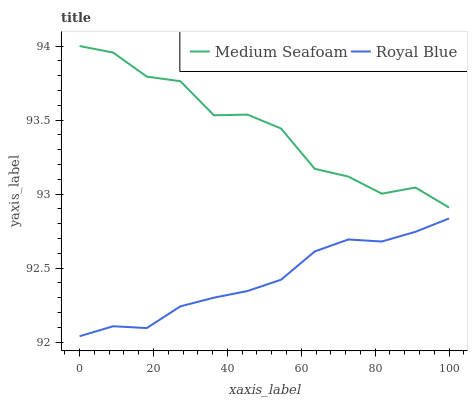Does Royal Blue have the minimum area under the curve?
Answer yes or no. Yes. Does Medium Seafoam have the maximum area under the curve?
Answer yes or no. Yes. Does Medium Seafoam have the minimum area under the curve?
Answer yes or no. No. Is Royal Blue the smoothest?
Answer yes or no. Yes. Is Medium Seafoam the roughest?
Answer yes or no. Yes. Is Medium Seafoam the smoothest?
Answer yes or no. No. Does Medium Seafoam have the lowest value?
Answer yes or no. No. Is Royal Blue less than Medium Seafoam?
Answer yes or no. Yes. Is Medium Seafoam greater than Royal Blue?
Answer yes or no. Yes. Does Royal Blue intersect Medium Seafoam?
Answer yes or no. No. 